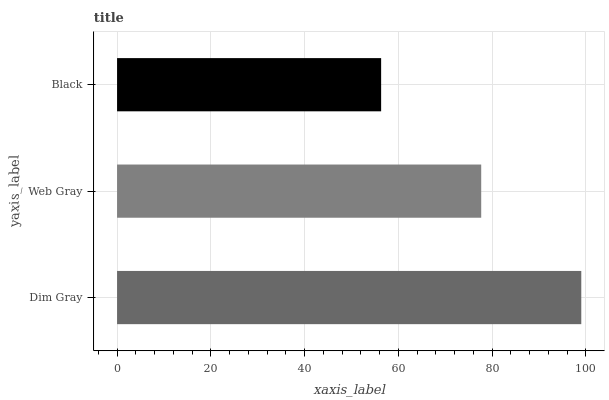Is Black the minimum?
Answer yes or no. Yes. Is Dim Gray the maximum?
Answer yes or no. Yes. Is Web Gray the minimum?
Answer yes or no. No. Is Web Gray the maximum?
Answer yes or no. No. Is Dim Gray greater than Web Gray?
Answer yes or no. Yes. Is Web Gray less than Dim Gray?
Answer yes or no. Yes. Is Web Gray greater than Dim Gray?
Answer yes or no. No. Is Dim Gray less than Web Gray?
Answer yes or no. No. Is Web Gray the high median?
Answer yes or no. Yes. Is Web Gray the low median?
Answer yes or no. Yes. Is Dim Gray the high median?
Answer yes or no. No. Is Dim Gray the low median?
Answer yes or no. No. 